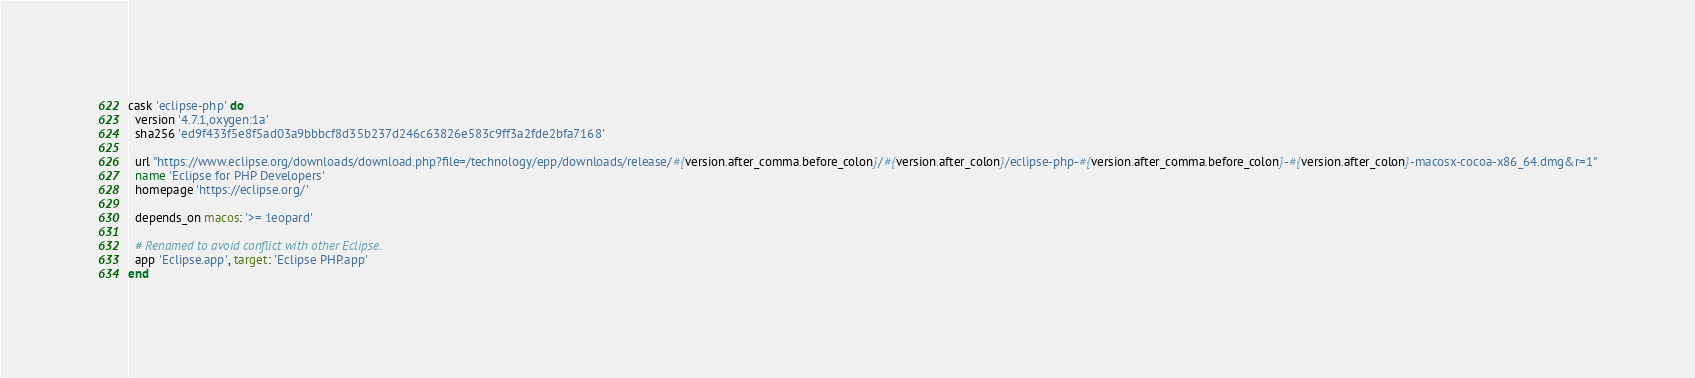Convert code to text. <code><loc_0><loc_0><loc_500><loc_500><_Ruby_>cask 'eclipse-php' do
  version '4.7.1,oxygen:1a'
  sha256 'ed9f433f5e8f5ad03a9bbbcf8d35b237d246c63826e583c9ff3a2fde2bfa7168'

  url "https://www.eclipse.org/downloads/download.php?file=/technology/epp/downloads/release/#{version.after_comma.before_colon}/#{version.after_colon}/eclipse-php-#{version.after_comma.before_colon}-#{version.after_colon}-macosx-cocoa-x86_64.dmg&r=1"
  name 'Eclipse for PHP Developers'
  homepage 'https://eclipse.org/'

  depends_on macos: '>= :leopard'

  # Renamed to avoid conflict with other Eclipse.
  app 'Eclipse.app', target: 'Eclipse PHP.app'
end
</code> 